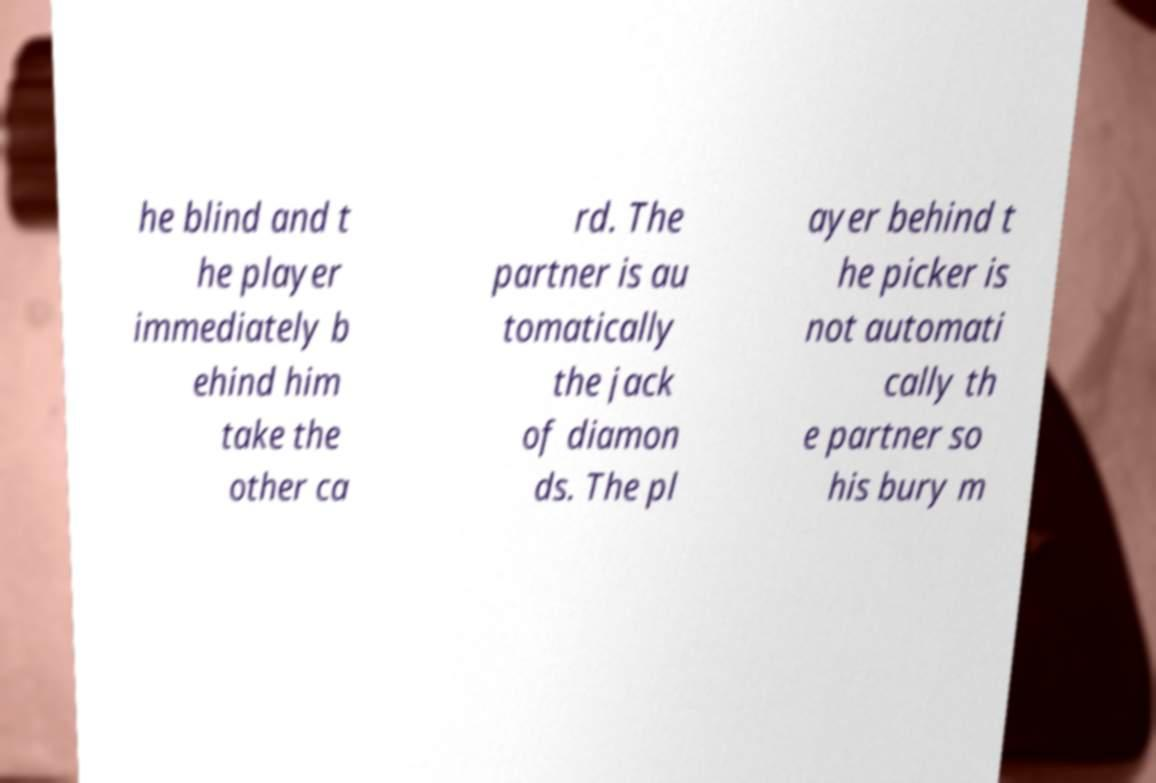Could you extract and type out the text from this image? he blind and t he player immediately b ehind him take the other ca rd. The partner is au tomatically the jack of diamon ds. The pl ayer behind t he picker is not automati cally th e partner so his bury m 